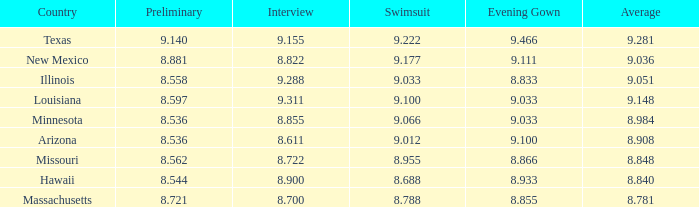What was the typical score for the country that had a 9.100 score in the evening gown category? 1.0. 